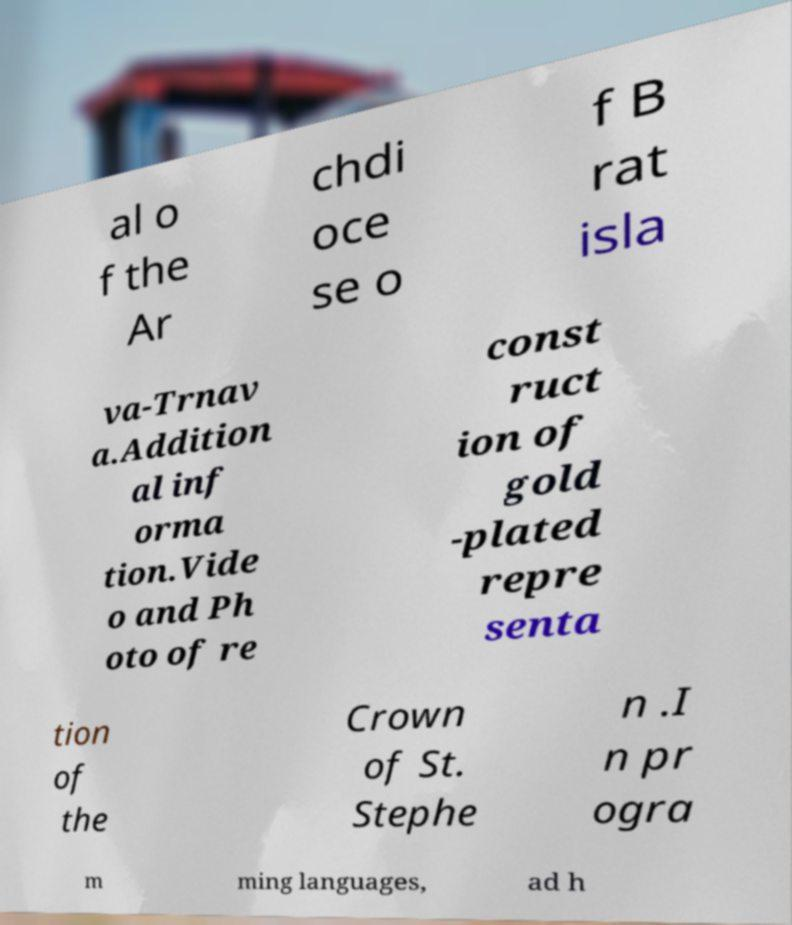For documentation purposes, I need the text within this image transcribed. Could you provide that? al o f the Ar chdi oce se o f B rat isla va-Trnav a.Addition al inf orma tion.Vide o and Ph oto of re const ruct ion of gold -plated repre senta tion of the Crown of St. Stephe n .I n pr ogra m ming languages, ad h 